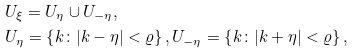<formula> <loc_0><loc_0><loc_500><loc_500>& U _ { \xi } = U _ { \eta } \cup U _ { - \eta } , \\ & U _ { \eta } = \left \{ k \colon | k - \eta | < \varrho \right \} , U _ { - \eta } = \left \{ k \colon | k + \eta | < \varrho \right \} ,</formula> 